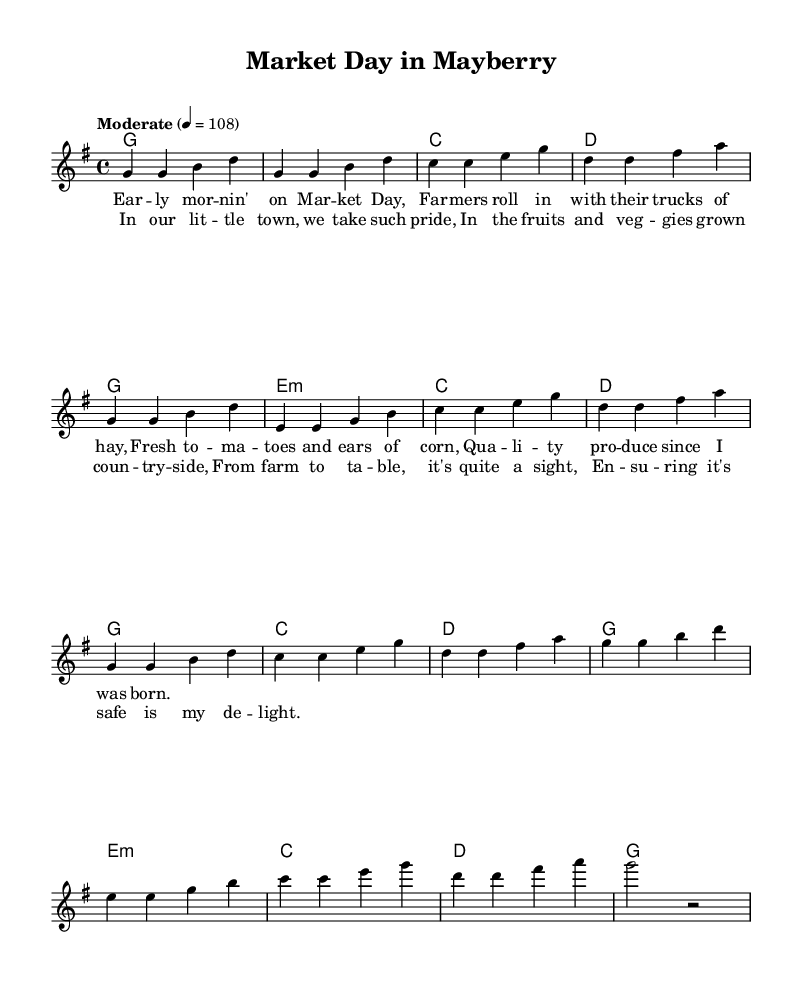What is the key signature of this music? The key signature is indicated towards the beginning of the sheet music. It states "g" which signifies the G major scale. This scale has one sharp (F#), which is confirmed by the context of the notes.
Answer: G major What is the time signature of this music? The time signature is found right after the key signature at the beginning of the score. It reads "4/4," which means there are four beats per measure and the quarter note gets one beat.
Answer: 4/4 What is the tempo marking of this piece? The tempo marking appears beneath the time signature and indicates the speed of the music. It states "Moderate" followed by a note value of 108. This indicates how many beats per minute the piece should be played.
Answer: Moderate 4 = 108 What is the first note of the chorus? To find the first note of the chorus, one needs to locate the section labeled "chorus." The first note of this section begins at the start of the melody. The note corresponds to the note "g," which is determined visually from the sheet music.
Answer: g How many measures are in the verse section? The verse section starts immediately after the heading and consists of two parts, both of which are divided into measures. Counting the measures systematically within this section shows it consists of 8 measures total.
Answer: 8 What type of produce is emphasized in the lyrics? The lyrics mention specific types of produce like tomatoes and corn, indicating a focus on fresh local produce. The context of the song and the lyrics clearly illustrate the theme of farmers' markets and their offerings.
Answer: Tomatoes and corn How does the chorus reflect themes of local pride? The chorus describes taking pride in local produce by stating that the town takes pride in the fruits and vegetables grown in their countryside. This reflects a deep connection between the community and its local agriculture. The reasoning shows how the lyrics exemplify local culture and pride.
Answer: Local pride 